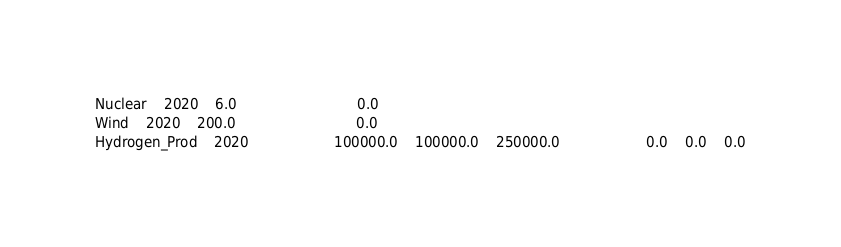<code> <loc_0><loc_0><loc_500><loc_500><_SQL_>Nuclear	2020	6.0							0.0						
Wind	2020	200.0							0.0						
Hydrogen_Prod	2020					100000.0	100000.0	250000.0					0.0	0.0	0.0
</code> 